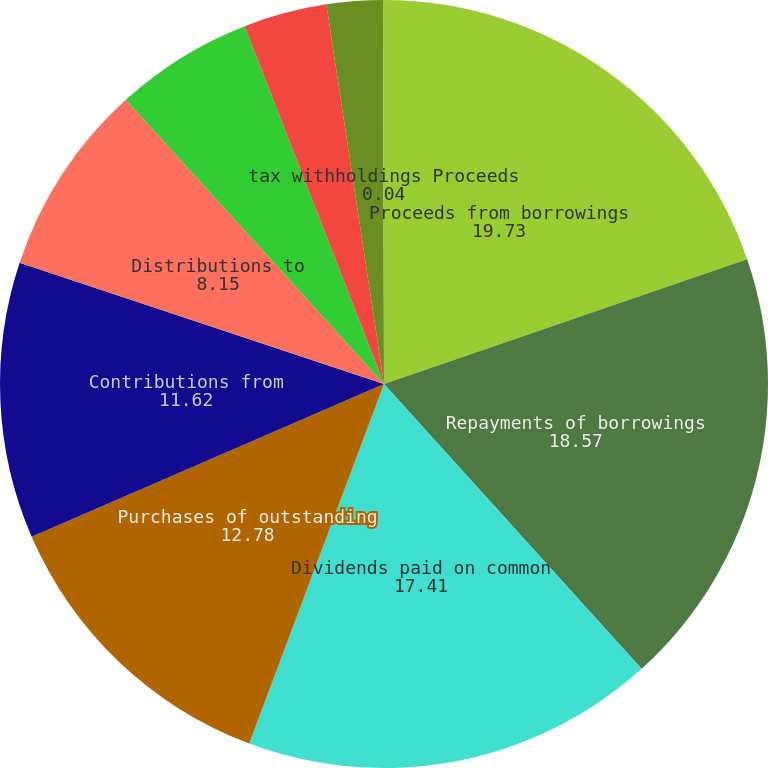Convert chart to OTSL. <chart><loc_0><loc_0><loc_500><loc_500><pie_chart><fcel>Proceeds from borrowings<fcel>Repayments of borrowings<fcel>Dividends paid on common<fcel>Purchases of outstanding<fcel>Contributions from<fcel>Distributions to<fcel>Dividends paid on preferred<fcel>Debt issuance and other costs<fcel>Repurchase of shares related<fcel>tax withholdings Proceeds<nl><fcel>19.73%<fcel>18.57%<fcel>17.41%<fcel>12.78%<fcel>11.62%<fcel>8.15%<fcel>5.83%<fcel>3.51%<fcel>2.36%<fcel>0.04%<nl></chart> 